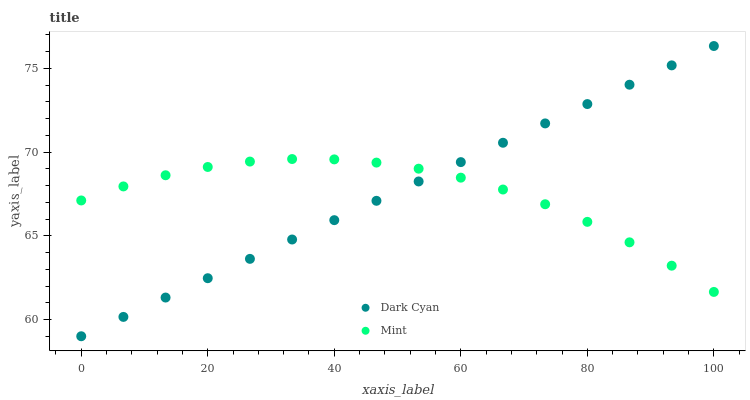Does Mint have the minimum area under the curve?
Answer yes or no. Yes. Does Dark Cyan have the maximum area under the curve?
Answer yes or no. Yes. Does Mint have the maximum area under the curve?
Answer yes or no. No. Is Dark Cyan the smoothest?
Answer yes or no. Yes. Is Mint the roughest?
Answer yes or no. Yes. Is Mint the smoothest?
Answer yes or no. No. Does Dark Cyan have the lowest value?
Answer yes or no. Yes. Does Mint have the lowest value?
Answer yes or no. No. Does Dark Cyan have the highest value?
Answer yes or no. Yes. Does Mint have the highest value?
Answer yes or no. No. Does Mint intersect Dark Cyan?
Answer yes or no. Yes. Is Mint less than Dark Cyan?
Answer yes or no. No. Is Mint greater than Dark Cyan?
Answer yes or no. No. 